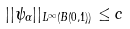Convert formula to latex. <formula><loc_0><loc_0><loc_500><loc_500>| | \psi _ { \alpha } | | _ { L ^ { \infty } ( B ( 0 , 1 ) ) } \leq c</formula> 